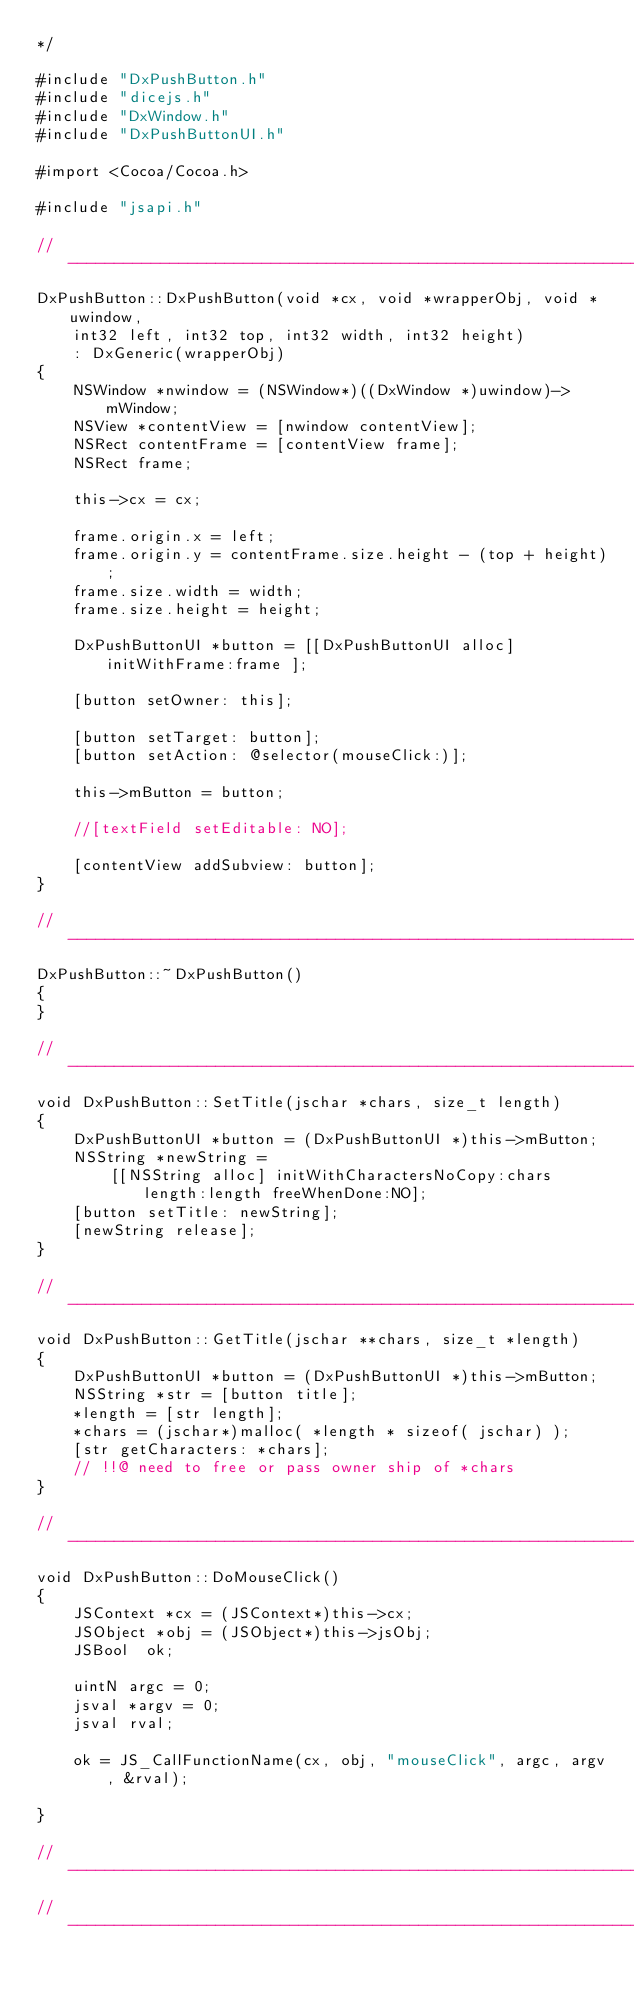Convert code to text. <code><loc_0><loc_0><loc_500><loc_500><_ObjectiveC_>*/

#include "DxPushButton.h"
#include "dicejs.h"
#include "DxWindow.h"
#include "DxPushButtonUI.h"

#import <Cocoa/Cocoa.h>

#include "jsapi.h"

// --------------------------------------------------------------------------------
DxPushButton::DxPushButton(void *cx, void *wrapperObj, void *uwindow, 
	int32 left, int32 top, int32 width, int32 height)
	: DxGeneric(wrapperObj)
{
	NSWindow *nwindow = (NSWindow*)((DxWindow *)uwindow)->mWindow;
	NSView *contentView = [nwindow contentView];
	NSRect contentFrame = [contentView frame];
	NSRect frame;
	
	this->cx = cx;
	
	frame.origin.x = left;
	frame.origin.y = contentFrame.size.height - (top + height);
	frame.size.width = width;
	frame.size.height = height;
	
	DxPushButtonUI *button = [[DxPushButtonUI alloc] initWithFrame:frame ];
	
	[button setOwner: this];
	
	[button setTarget: button];
	[button setAction: @selector(mouseClick:)];
	
	this->mButton = button;
	
	//[textField setEditable: NO];
	
	[contentView addSubview: button];
}

// --------------------------------------------------------------------------------
DxPushButton::~DxPushButton()
{
}

// --------------------------------------------------------------------------------
void DxPushButton::SetTitle(jschar *chars, size_t length)
{
	DxPushButtonUI *button = (DxPushButtonUI *)this->mButton;
	NSString *newString = 
		[[NSString alloc] initWithCharactersNoCopy:chars length:length freeWhenDone:NO];
	[button setTitle: newString];
	[newString release];
}

// --------------------------------------------------------------------------------
void DxPushButton::GetTitle(jschar **chars, size_t *length)
{
	DxPushButtonUI *button = (DxPushButtonUI *)this->mButton;
	NSString *str = [button title];
	*length = [str length];
	*chars = (jschar*)malloc( *length * sizeof( jschar) );
	[str getCharacters: *chars];
	// !!@ need to free or pass owner ship of *chars
}

// --------------------------------------------------------------------------------
void DxPushButton::DoMouseClick()
{
	JSContext *cx = (JSContext*)this->cx;
	JSObject *obj = (JSObject*)this->jsObj;
	JSBool	ok;
	
    uintN argc = 0;
	jsval *argv = 0;
	jsval rval;
	
	ok = JS_CallFunctionName(cx, obj, "mouseClick", argc, argv, &rval);
	
}

// --------------------------------------------------------------------------------
// --------------------------------------------------------------------------------
</code> 